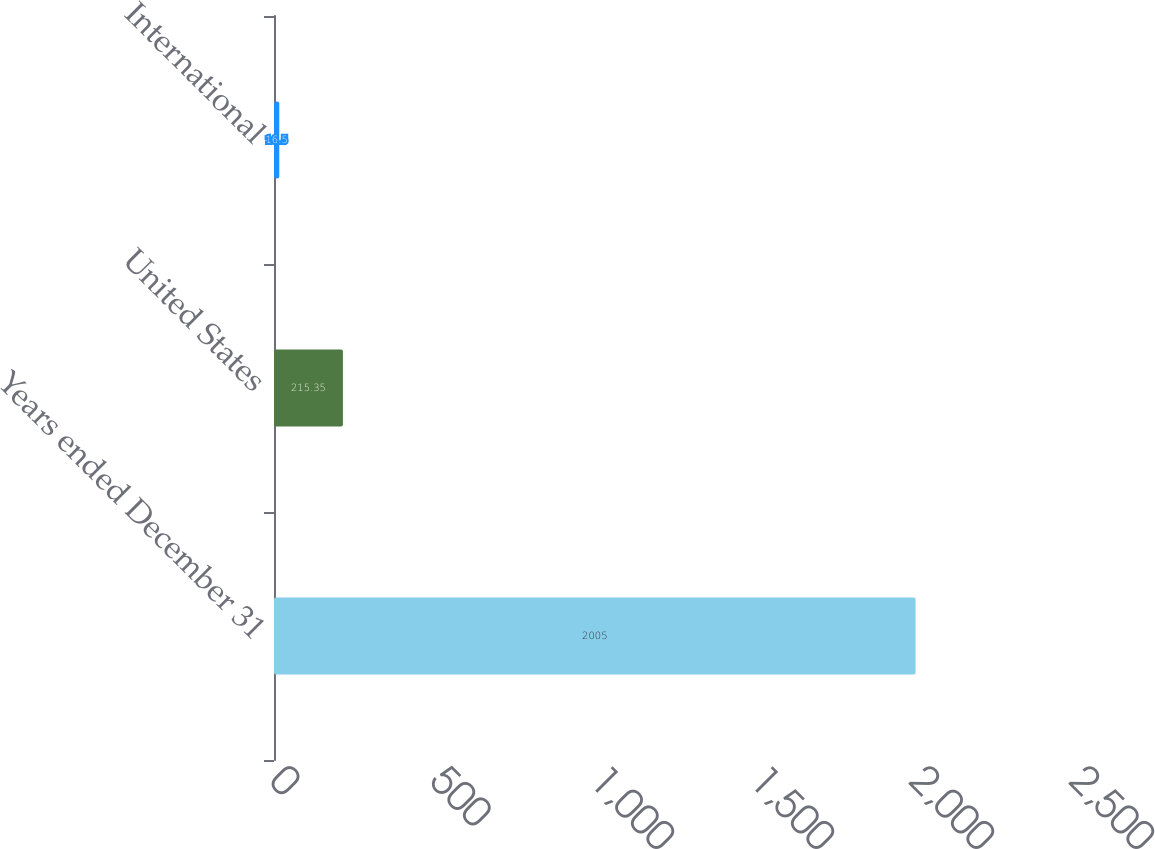Convert chart to OTSL. <chart><loc_0><loc_0><loc_500><loc_500><bar_chart><fcel>Years ended December 31<fcel>United States<fcel>International<nl><fcel>2005<fcel>215.35<fcel>16.5<nl></chart> 